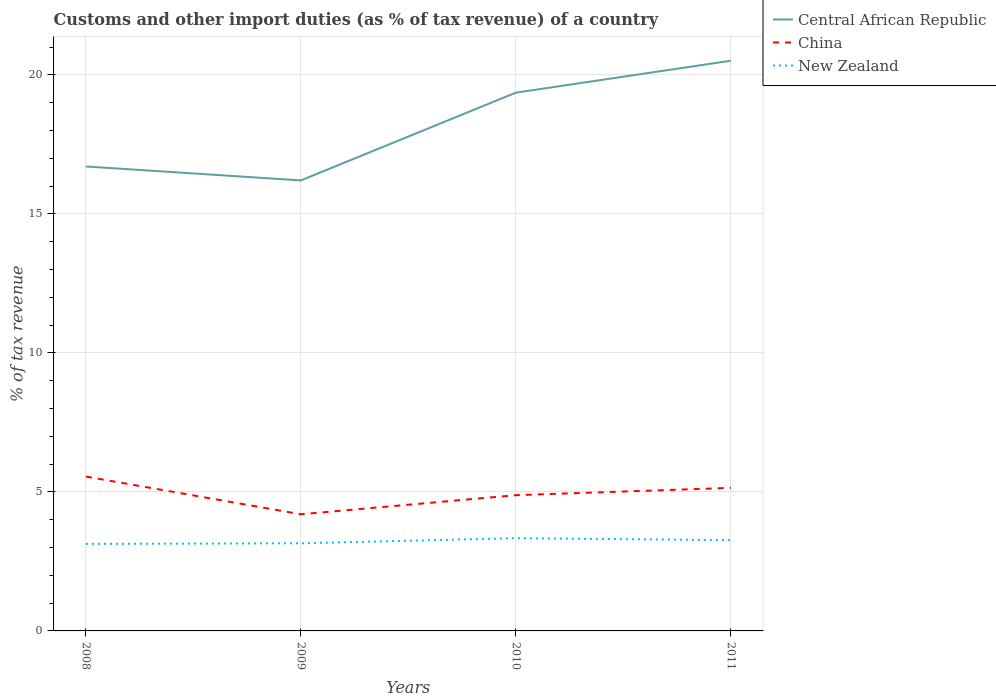Does the line corresponding to Central African Republic intersect with the line corresponding to China?
Ensure brevity in your answer.  No. Is the number of lines equal to the number of legend labels?
Ensure brevity in your answer.  Yes. Across all years, what is the maximum percentage of tax revenue from customs in Central African Republic?
Provide a short and direct response. 16.2. What is the total percentage of tax revenue from customs in New Zealand in the graph?
Keep it short and to the point. -0.02. What is the difference between the highest and the second highest percentage of tax revenue from customs in New Zealand?
Keep it short and to the point. 0.21. What is the difference between the highest and the lowest percentage of tax revenue from customs in New Zealand?
Keep it short and to the point. 2. How many years are there in the graph?
Your answer should be very brief. 4. Does the graph contain grids?
Ensure brevity in your answer.  Yes. Where does the legend appear in the graph?
Offer a very short reply. Top right. How are the legend labels stacked?
Your answer should be compact. Vertical. What is the title of the graph?
Provide a short and direct response. Customs and other import duties (as % of tax revenue) of a country. Does "Mali" appear as one of the legend labels in the graph?
Offer a terse response. No. What is the label or title of the Y-axis?
Offer a terse response. % of tax revenue. What is the % of tax revenue in Central African Republic in 2008?
Your response must be concise. 16.7. What is the % of tax revenue in China in 2008?
Your response must be concise. 5.55. What is the % of tax revenue of New Zealand in 2008?
Keep it short and to the point. 3.13. What is the % of tax revenue of Central African Republic in 2009?
Offer a very short reply. 16.2. What is the % of tax revenue in China in 2009?
Ensure brevity in your answer.  4.2. What is the % of tax revenue of New Zealand in 2009?
Your answer should be compact. 3.15. What is the % of tax revenue of Central African Republic in 2010?
Ensure brevity in your answer.  19.36. What is the % of tax revenue of China in 2010?
Keep it short and to the point. 4.88. What is the % of tax revenue of New Zealand in 2010?
Keep it short and to the point. 3.34. What is the % of tax revenue of Central African Republic in 2011?
Offer a very short reply. 20.51. What is the % of tax revenue in China in 2011?
Offer a very short reply. 5.14. What is the % of tax revenue in New Zealand in 2011?
Ensure brevity in your answer.  3.27. Across all years, what is the maximum % of tax revenue in Central African Republic?
Keep it short and to the point. 20.51. Across all years, what is the maximum % of tax revenue of China?
Your response must be concise. 5.55. Across all years, what is the maximum % of tax revenue of New Zealand?
Provide a short and direct response. 3.34. Across all years, what is the minimum % of tax revenue of Central African Republic?
Your answer should be very brief. 16.2. Across all years, what is the minimum % of tax revenue in China?
Provide a succinct answer. 4.2. Across all years, what is the minimum % of tax revenue in New Zealand?
Keep it short and to the point. 3.13. What is the total % of tax revenue in Central African Republic in the graph?
Give a very brief answer. 72.77. What is the total % of tax revenue in China in the graph?
Offer a very short reply. 19.77. What is the total % of tax revenue of New Zealand in the graph?
Make the answer very short. 12.88. What is the difference between the % of tax revenue in Central African Republic in 2008 and that in 2009?
Provide a succinct answer. 0.5. What is the difference between the % of tax revenue of China in 2008 and that in 2009?
Your answer should be compact. 1.36. What is the difference between the % of tax revenue of New Zealand in 2008 and that in 2009?
Keep it short and to the point. -0.02. What is the difference between the % of tax revenue of Central African Republic in 2008 and that in 2010?
Ensure brevity in your answer.  -2.65. What is the difference between the % of tax revenue in China in 2008 and that in 2010?
Ensure brevity in your answer.  0.67. What is the difference between the % of tax revenue in New Zealand in 2008 and that in 2010?
Offer a very short reply. -0.21. What is the difference between the % of tax revenue of Central African Republic in 2008 and that in 2011?
Keep it short and to the point. -3.8. What is the difference between the % of tax revenue in China in 2008 and that in 2011?
Give a very brief answer. 0.41. What is the difference between the % of tax revenue in New Zealand in 2008 and that in 2011?
Ensure brevity in your answer.  -0.14. What is the difference between the % of tax revenue in Central African Republic in 2009 and that in 2010?
Your answer should be very brief. -3.16. What is the difference between the % of tax revenue of China in 2009 and that in 2010?
Give a very brief answer. -0.69. What is the difference between the % of tax revenue in New Zealand in 2009 and that in 2010?
Offer a very short reply. -0.18. What is the difference between the % of tax revenue of Central African Republic in 2009 and that in 2011?
Offer a terse response. -4.3. What is the difference between the % of tax revenue of China in 2009 and that in 2011?
Provide a succinct answer. -0.95. What is the difference between the % of tax revenue of New Zealand in 2009 and that in 2011?
Your response must be concise. -0.11. What is the difference between the % of tax revenue in Central African Republic in 2010 and that in 2011?
Offer a terse response. -1.15. What is the difference between the % of tax revenue in China in 2010 and that in 2011?
Your answer should be compact. -0.26. What is the difference between the % of tax revenue in New Zealand in 2010 and that in 2011?
Your answer should be very brief. 0.07. What is the difference between the % of tax revenue of Central African Republic in 2008 and the % of tax revenue of China in 2009?
Offer a very short reply. 12.51. What is the difference between the % of tax revenue in Central African Republic in 2008 and the % of tax revenue in New Zealand in 2009?
Provide a succinct answer. 13.55. What is the difference between the % of tax revenue of China in 2008 and the % of tax revenue of New Zealand in 2009?
Keep it short and to the point. 2.4. What is the difference between the % of tax revenue of Central African Republic in 2008 and the % of tax revenue of China in 2010?
Your answer should be very brief. 11.82. What is the difference between the % of tax revenue of Central African Republic in 2008 and the % of tax revenue of New Zealand in 2010?
Offer a terse response. 13.37. What is the difference between the % of tax revenue in China in 2008 and the % of tax revenue in New Zealand in 2010?
Make the answer very short. 2.21. What is the difference between the % of tax revenue of Central African Republic in 2008 and the % of tax revenue of China in 2011?
Offer a very short reply. 11.56. What is the difference between the % of tax revenue in Central African Republic in 2008 and the % of tax revenue in New Zealand in 2011?
Give a very brief answer. 13.44. What is the difference between the % of tax revenue in China in 2008 and the % of tax revenue in New Zealand in 2011?
Give a very brief answer. 2.29. What is the difference between the % of tax revenue in Central African Republic in 2009 and the % of tax revenue in China in 2010?
Offer a very short reply. 11.32. What is the difference between the % of tax revenue of Central African Republic in 2009 and the % of tax revenue of New Zealand in 2010?
Ensure brevity in your answer.  12.87. What is the difference between the % of tax revenue in China in 2009 and the % of tax revenue in New Zealand in 2010?
Your response must be concise. 0.86. What is the difference between the % of tax revenue in Central African Republic in 2009 and the % of tax revenue in China in 2011?
Ensure brevity in your answer.  11.06. What is the difference between the % of tax revenue in Central African Republic in 2009 and the % of tax revenue in New Zealand in 2011?
Provide a short and direct response. 12.94. What is the difference between the % of tax revenue in China in 2009 and the % of tax revenue in New Zealand in 2011?
Provide a succinct answer. 0.93. What is the difference between the % of tax revenue in Central African Republic in 2010 and the % of tax revenue in China in 2011?
Offer a terse response. 14.21. What is the difference between the % of tax revenue of Central African Republic in 2010 and the % of tax revenue of New Zealand in 2011?
Offer a very short reply. 16.09. What is the difference between the % of tax revenue of China in 2010 and the % of tax revenue of New Zealand in 2011?
Make the answer very short. 1.62. What is the average % of tax revenue in Central African Republic per year?
Your answer should be compact. 18.19. What is the average % of tax revenue of China per year?
Give a very brief answer. 4.94. What is the average % of tax revenue of New Zealand per year?
Keep it short and to the point. 3.22. In the year 2008, what is the difference between the % of tax revenue in Central African Republic and % of tax revenue in China?
Offer a very short reply. 11.15. In the year 2008, what is the difference between the % of tax revenue of Central African Republic and % of tax revenue of New Zealand?
Your answer should be very brief. 13.57. In the year 2008, what is the difference between the % of tax revenue of China and % of tax revenue of New Zealand?
Your response must be concise. 2.42. In the year 2009, what is the difference between the % of tax revenue of Central African Republic and % of tax revenue of China?
Your response must be concise. 12.01. In the year 2009, what is the difference between the % of tax revenue of Central African Republic and % of tax revenue of New Zealand?
Offer a terse response. 13.05. In the year 2009, what is the difference between the % of tax revenue in China and % of tax revenue in New Zealand?
Your answer should be compact. 1.04. In the year 2010, what is the difference between the % of tax revenue in Central African Republic and % of tax revenue in China?
Your response must be concise. 14.48. In the year 2010, what is the difference between the % of tax revenue in Central African Republic and % of tax revenue in New Zealand?
Ensure brevity in your answer.  16.02. In the year 2010, what is the difference between the % of tax revenue of China and % of tax revenue of New Zealand?
Your response must be concise. 1.55. In the year 2011, what is the difference between the % of tax revenue of Central African Republic and % of tax revenue of China?
Your answer should be compact. 15.36. In the year 2011, what is the difference between the % of tax revenue of Central African Republic and % of tax revenue of New Zealand?
Provide a short and direct response. 17.24. In the year 2011, what is the difference between the % of tax revenue of China and % of tax revenue of New Zealand?
Provide a succinct answer. 1.88. What is the ratio of the % of tax revenue of Central African Republic in 2008 to that in 2009?
Your response must be concise. 1.03. What is the ratio of the % of tax revenue in China in 2008 to that in 2009?
Offer a very short reply. 1.32. What is the ratio of the % of tax revenue in Central African Republic in 2008 to that in 2010?
Your response must be concise. 0.86. What is the ratio of the % of tax revenue in China in 2008 to that in 2010?
Keep it short and to the point. 1.14. What is the ratio of the % of tax revenue of New Zealand in 2008 to that in 2010?
Keep it short and to the point. 0.94. What is the ratio of the % of tax revenue of Central African Republic in 2008 to that in 2011?
Offer a terse response. 0.81. What is the ratio of the % of tax revenue of China in 2008 to that in 2011?
Keep it short and to the point. 1.08. What is the ratio of the % of tax revenue of New Zealand in 2008 to that in 2011?
Ensure brevity in your answer.  0.96. What is the ratio of the % of tax revenue of Central African Republic in 2009 to that in 2010?
Provide a succinct answer. 0.84. What is the ratio of the % of tax revenue in China in 2009 to that in 2010?
Your response must be concise. 0.86. What is the ratio of the % of tax revenue of New Zealand in 2009 to that in 2010?
Offer a terse response. 0.94. What is the ratio of the % of tax revenue in Central African Republic in 2009 to that in 2011?
Provide a short and direct response. 0.79. What is the ratio of the % of tax revenue of China in 2009 to that in 2011?
Offer a very short reply. 0.82. What is the ratio of the % of tax revenue in New Zealand in 2009 to that in 2011?
Provide a succinct answer. 0.97. What is the ratio of the % of tax revenue in Central African Republic in 2010 to that in 2011?
Provide a short and direct response. 0.94. What is the ratio of the % of tax revenue of China in 2010 to that in 2011?
Ensure brevity in your answer.  0.95. What is the ratio of the % of tax revenue of New Zealand in 2010 to that in 2011?
Make the answer very short. 1.02. What is the difference between the highest and the second highest % of tax revenue of Central African Republic?
Provide a succinct answer. 1.15. What is the difference between the highest and the second highest % of tax revenue of China?
Offer a terse response. 0.41. What is the difference between the highest and the second highest % of tax revenue of New Zealand?
Make the answer very short. 0.07. What is the difference between the highest and the lowest % of tax revenue of Central African Republic?
Give a very brief answer. 4.3. What is the difference between the highest and the lowest % of tax revenue of China?
Your answer should be compact. 1.36. What is the difference between the highest and the lowest % of tax revenue in New Zealand?
Your answer should be very brief. 0.21. 